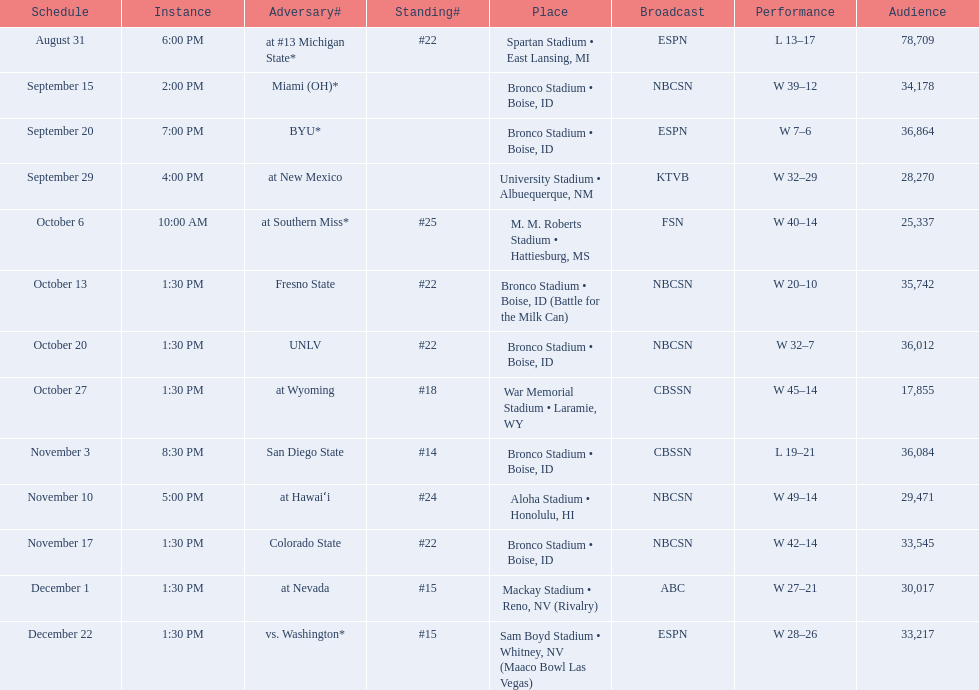Who were all of the opponents? At #13 michigan state*, miami (oh)*, byu*, at new mexico, at southern miss*, fresno state, unlv, at wyoming, san diego state, at hawaiʻi, colorado state, at nevada, vs. washington*. Who did they face on november 3rd? San Diego State. What rank were they on november 3rd? #14. 